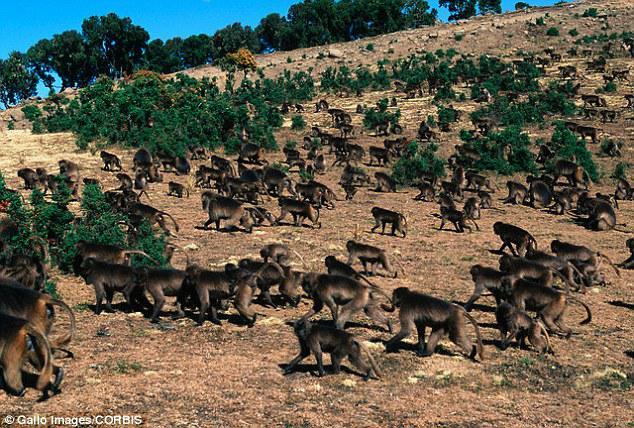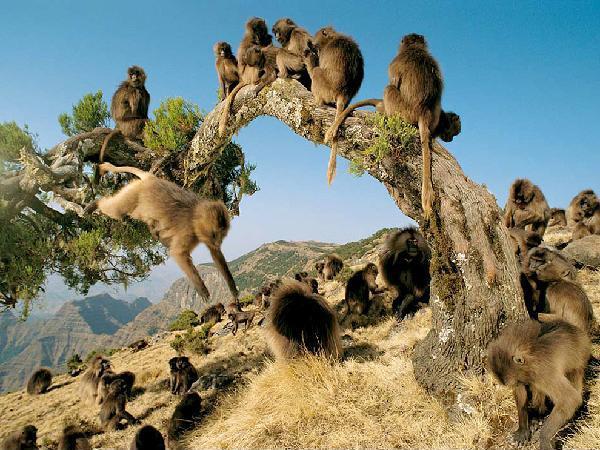The first image is the image on the left, the second image is the image on the right. For the images shown, is this caption "There are two groups of monkeys in the center of the images." true? Answer yes or no. Yes. 